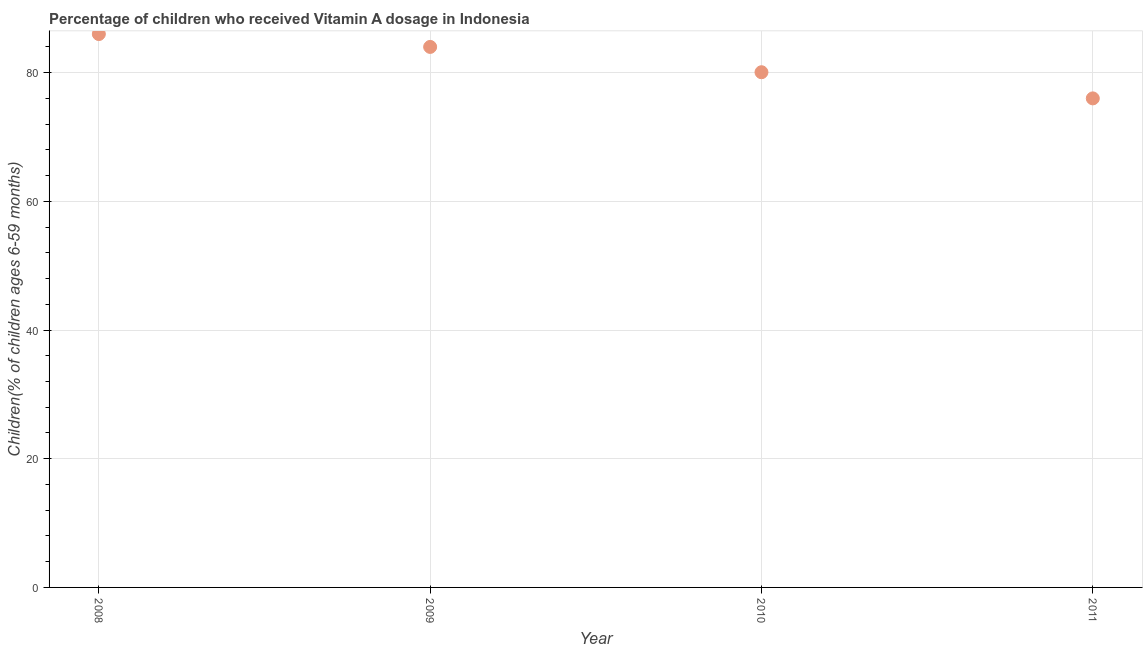What is the vitamin a supplementation coverage rate in 2008?
Your answer should be compact. 86. In which year was the vitamin a supplementation coverage rate maximum?
Give a very brief answer. 2008. In which year was the vitamin a supplementation coverage rate minimum?
Your answer should be very brief. 2011. What is the sum of the vitamin a supplementation coverage rate?
Make the answer very short. 326.07. What is the difference between the vitamin a supplementation coverage rate in 2009 and 2010?
Keep it short and to the point. 3.93. What is the average vitamin a supplementation coverage rate per year?
Offer a very short reply. 81.52. What is the median vitamin a supplementation coverage rate?
Your answer should be very brief. 82.03. Do a majority of the years between 2009 and 2010 (inclusive) have vitamin a supplementation coverage rate greater than 68 %?
Ensure brevity in your answer.  Yes. What is the ratio of the vitamin a supplementation coverage rate in 2010 to that in 2011?
Provide a short and direct response. 1.05. Is the vitamin a supplementation coverage rate in 2009 less than that in 2010?
Provide a succinct answer. No. Is the difference between the vitamin a supplementation coverage rate in 2008 and 2011 greater than the difference between any two years?
Provide a short and direct response. Yes. What is the difference between the highest and the second highest vitamin a supplementation coverage rate?
Make the answer very short. 2. What is the difference between the highest and the lowest vitamin a supplementation coverage rate?
Offer a very short reply. 10. In how many years, is the vitamin a supplementation coverage rate greater than the average vitamin a supplementation coverage rate taken over all years?
Your answer should be compact. 2. How many dotlines are there?
Your response must be concise. 1. How many years are there in the graph?
Offer a very short reply. 4. Does the graph contain grids?
Offer a terse response. Yes. What is the title of the graph?
Make the answer very short. Percentage of children who received Vitamin A dosage in Indonesia. What is the label or title of the Y-axis?
Ensure brevity in your answer.  Children(% of children ages 6-59 months). What is the Children(% of children ages 6-59 months) in 2008?
Offer a terse response. 86. What is the Children(% of children ages 6-59 months) in 2010?
Make the answer very short. 80.07. What is the Children(% of children ages 6-59 months) in 2011?
Ensure brevity in your answer.  76. What is the difference between the Children(% of children ages 6-59 months) in 2008 and 2010?
Your response must be concise. 5.93. What is the difference between the Children(% of children ages 6-59 months) in 2009 and 2010?
Provide a short and direct response. 3.93. What is the difference between the Children(% of children ages 6-59 months) in 2009 and 2011?
Your answer should be compact. 8. What is the difference between the Children(% of children ages 6-59 months) in 2010 and 2011?
Make the answer very short. 4.07. What is the ratio of the Children(% of children ages 6-59 months) in 2008 to that in 2009?
Provide a succinct answer. 1.02. What is the ratio of the Children(% of children ages 6-59 months) in 2008 to that in 2010?
Ensure brevity in your answer.  1.07. What is the ratio of the Children(% of children ages 6-59 months) in 2008 to that in 2011?
Provide a short and direct response. 1.13. What is the ratio of the Children(% of children ages 6-59 months) in 2009 to that in 2010?
Offer a terse response. 1.05. What is the ratio of the Children(% of children ages 6-59 months) in 2009 to that in 2011?
Provide a succinct answer. 1.1. What is the ratio of the Children(% of children ages 6-59 months) in 2010 to that in 2011?
Your response must be concise. 1.05. 